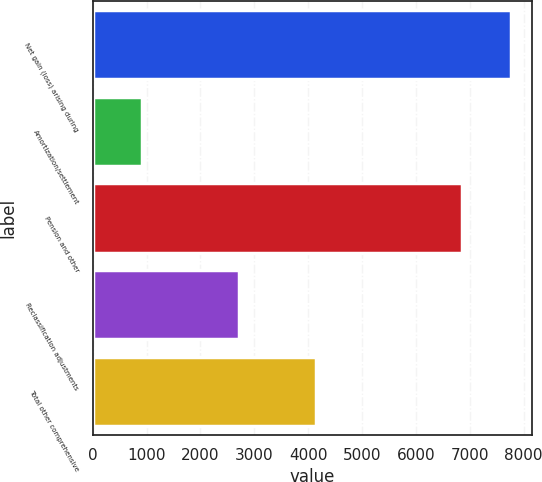Convert chart. <chart><loc_0><loc_0><loc_500><loc_500><bar_chart><fcel>Net gain (loss) arising during<fcel>Amortization/settlement<fcel>Pension and other<fcel>Reclassification adjustments<fcel>Total other comprehensive<nl><fcel>7767<fcel>915<fcel>6852<fcel>2713<fcel>4139<nl></chart> 